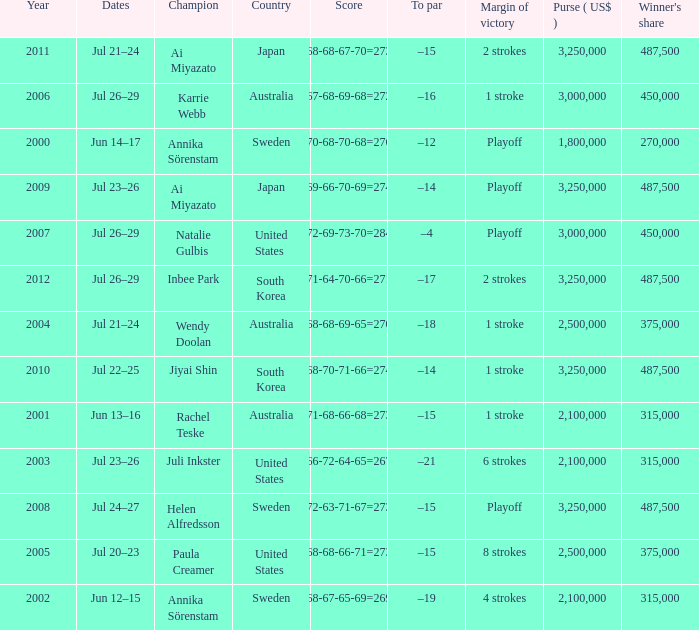Which Country has a Score of 70-68-70-68=276? Sweden. 